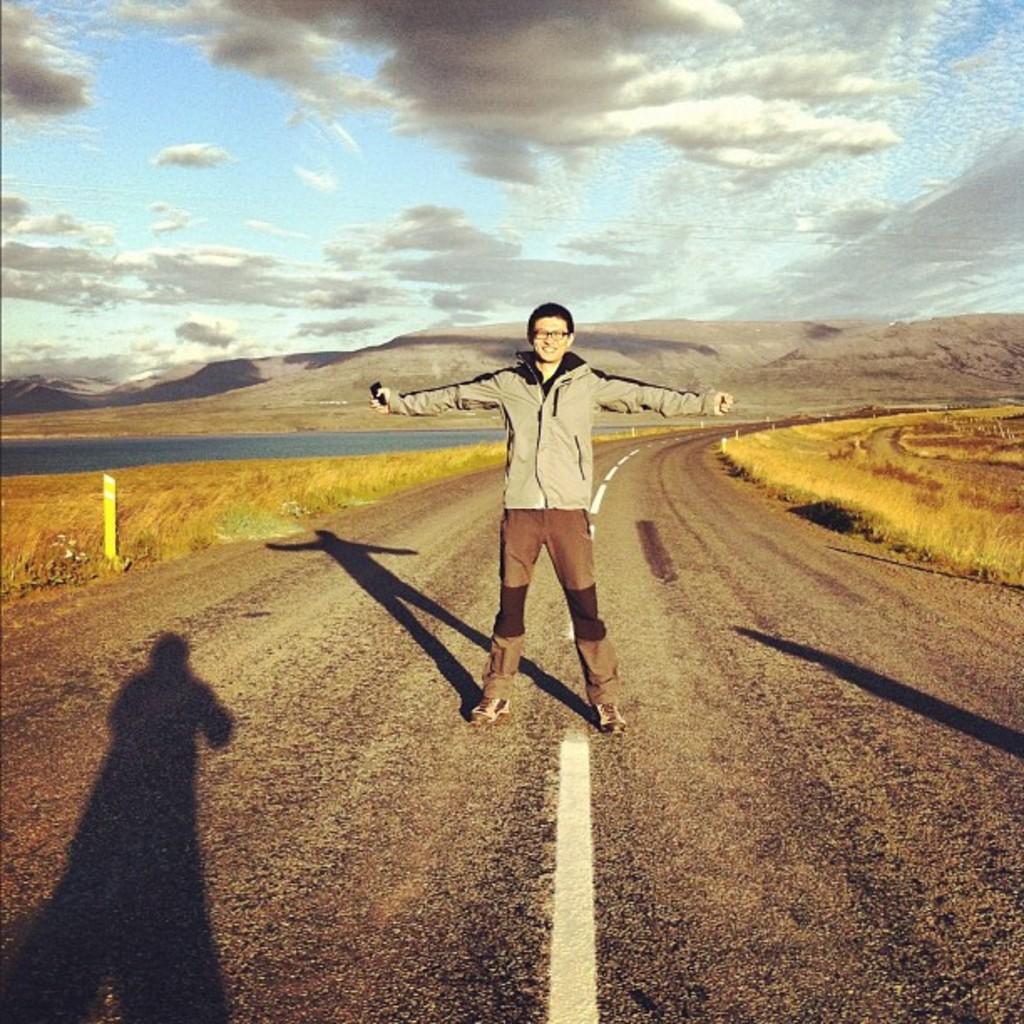How would you summarize this image in a sentence or two? In this picture there is a man standing on the road. We can observe a shadow of another person here. On either sides of this road there is some dried grass. We can observe some water in the left side. In the background there are hills and a sky with clouds. 